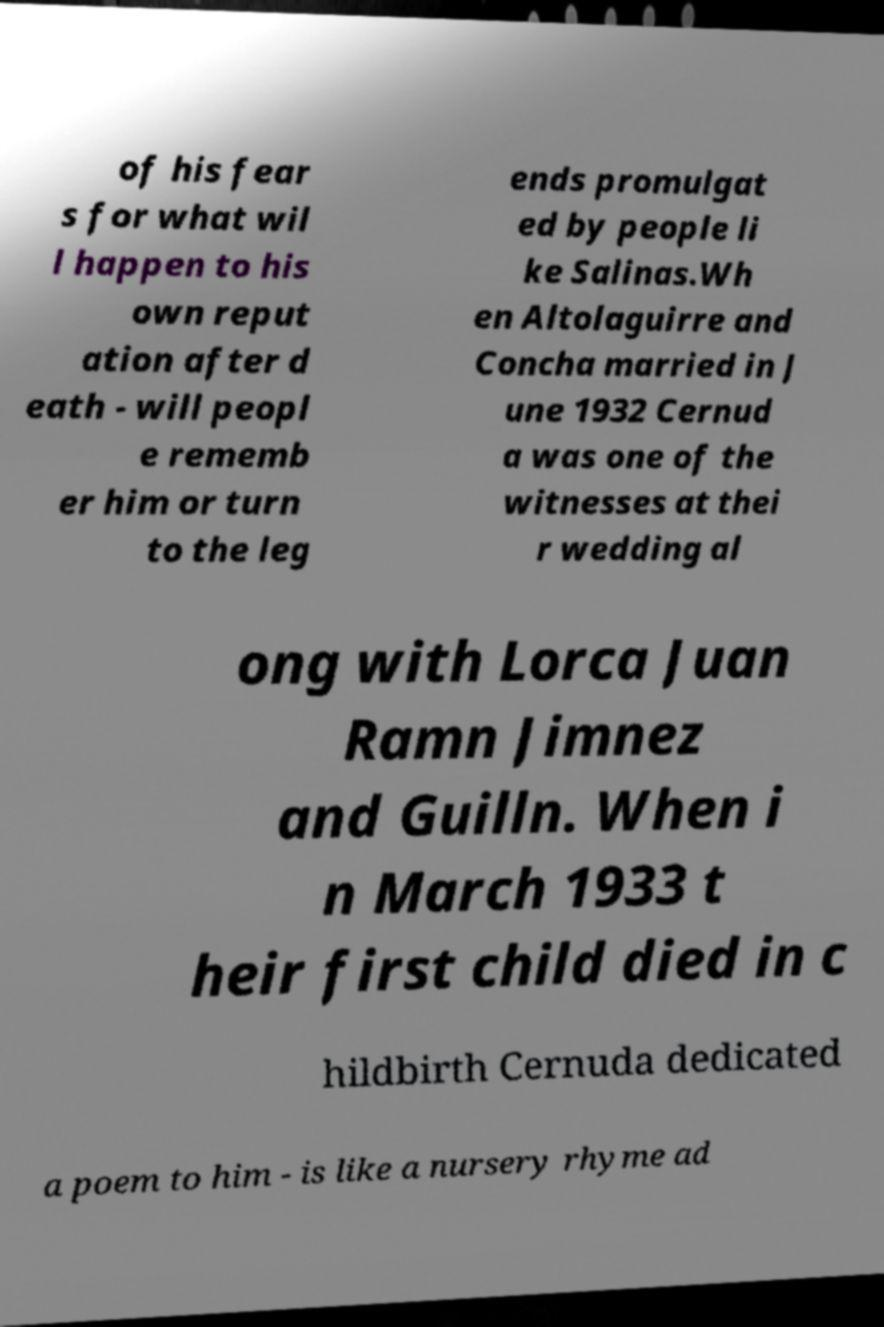Could you extract and type out the text from this image? of his fear s for what wil l happen to his own reput ation after d eath - will peopl e rememb er him or turn to the leg ends promulgat ed by people li ke Salinas.Wh en Altolaguirre and Concha married in J une 1932 Cernud a was one of the witnesses at thei r wedding al ong with Lorca Juan Ramn Jimnez and Guilln. When i n March 1933 t heir first child died in c hildbirth Cernuda dedicated a poem to him - is like a nursery rhyme ad 